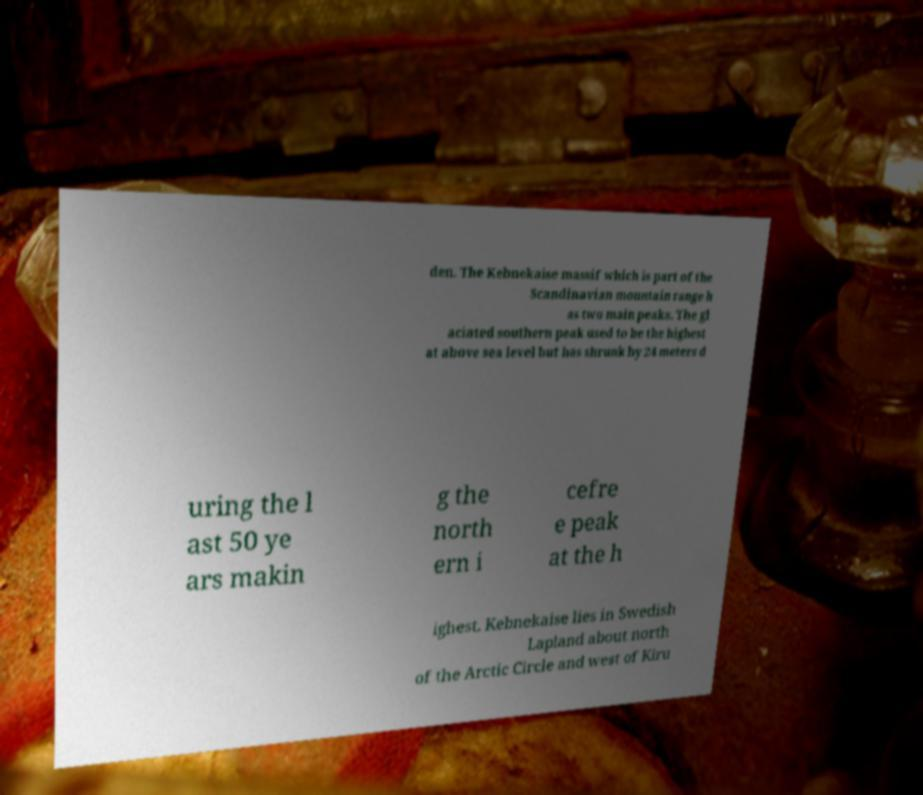I need the written content from this picture converted into text. Can you do that? den. The Kebnekaise massif which is part of the Scandinavian mountain range h as two main peaks. The gl aciated southern peak used to be the highest at above sea level but has shrunk by 24 meters d uring the l ast 50 ye ars makin g the north ern i cefre e peak at the h ighest. Kebnekaise lies in Swedish Lapland about north of the Arctic Circle and west of Kiru 